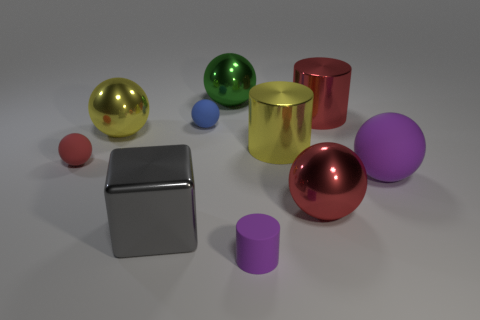Do the green metallic object and the red matte object have the same shape?
Offer a very short reply. Yes. There is a green sphere that is the same material as the large red cylinder; what size is it?
Give a very brief answer. Large. Is the size of the purple thing to the right of the rubber cylinder the same as the red ball left of the tiny purple cylinder?
Your answer should be very brief. No. There is a thing that is the same color as the tiny cylinder; what shape is it?
Keep it short and to the point. Sphere. Does the yellow ball have the same size as the red sphere that is on the left side of the big yellow metal sphere?
Your response must be concise. No. There is a cube that is the same size as the purple rubber ball; what is its color?
Keep it short and to the point. Gray. There is a small cylinder; is it the same color as the matte ball that is right of the large red metal ball?
Offer a very short reply. Yes. There is a big purple thing that is in front of the large cylinder right of the large red metallic ball; what is its material?
Your response must be concise. Rubber. What number of rubber spheres are both in front of the yellow ball and right of the gray block?
Your answer should be very brief. 1. How many other things are there of the same size as the gray metal thing?
Give a very brief answer. 6. 